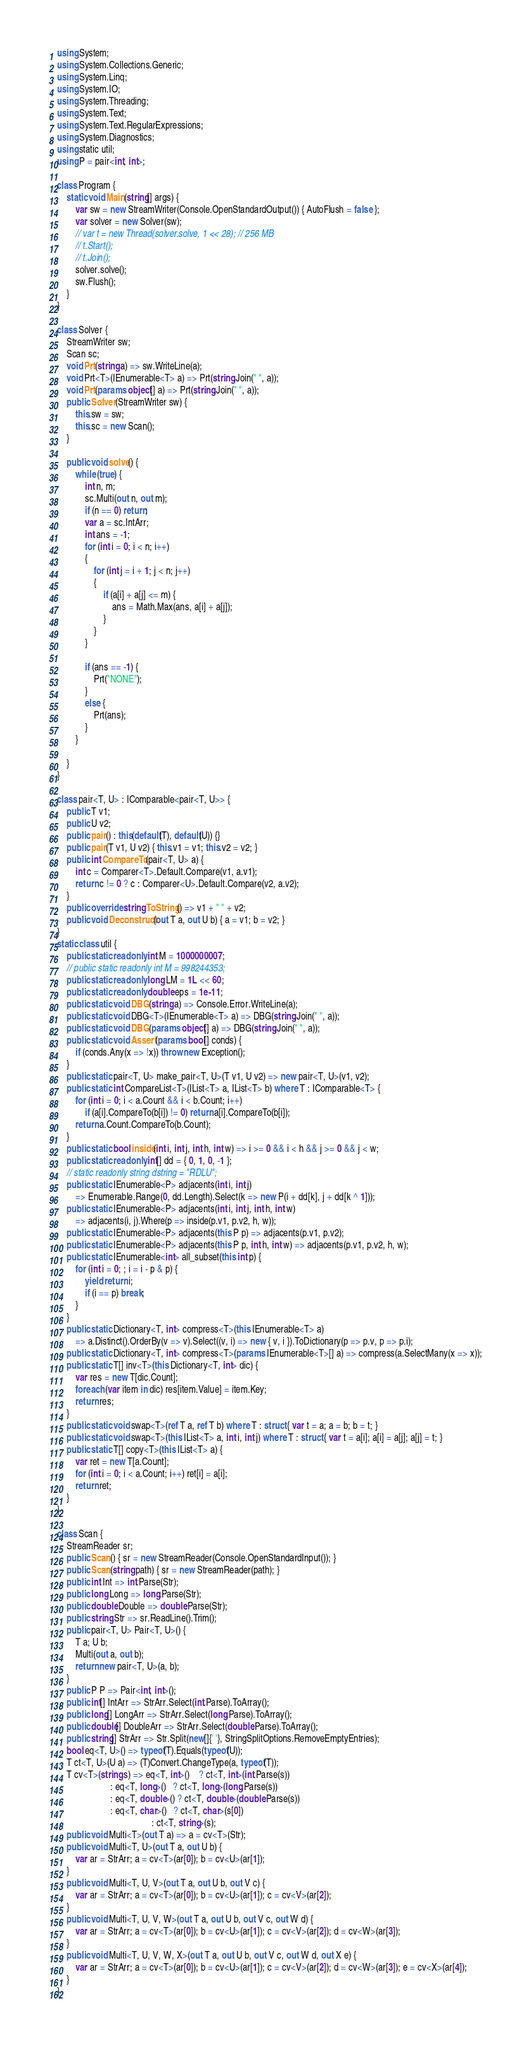<code> <loc_0><loc_0><loc_500><loc_500><_C#_>using System;
using System.Collections.Generic;
using System.Linq;
using System.IO;
using System.Threading;
using System.Text;
using System.Text.RegularExpressions;
using System.Diagnostics;
using static util;
using P = pair<int, int>;

class Program {
    static void Main(string[] args) {
        var sw = new StreamWriter(Console.OpenStandardOutput()) { AutoFlush = false };
        var solver = new Solver(sw);
        // var t = new Thread(solver.solve, 1 << 28); // 256 MB
        // t.Start();
        // t.Join();
        solver.solve();
        sw.Flush();
    }
}

class Solver {
    StreamWriter sw;
    Scan sc;
    void Prt(string a) => sw.WriteLine(a);
    void Prt<T>(IEnumerable<T> a) => Prt(string.Join(" ", a));
    void Prt(params object[] a) => Prt(string.Join(" ", a));
    public Solver(StreamWriter sw) {
        this.sw = sw;
        this.sc = new Scan();
    }

    public void solve() {
        while (true) {
            int n, m;
            sc.Multi(out n, out m);
            if (n == 0) return;
            var a = sc.IntArr;
            int ans = -1;
            for (int i = 0; i < n; i++)
            {
                for (int j = i + 1; j < n; j++)
                {
                    if (a[i] + a[j] <= m) {
                        ans = Math.Max(ans, a[i] + a[j]);
                    }
                }
            }

            if (ans == -1) {
                Prt("NONE");
            }
            else {
                Prt(ans);
            }
        }

    }
}

class pair<T, U> : IComparable<pair<T, U>> {
    public T v1;
    public U v2;
    public pair() : this(default(T), default(U)) {}
    public pair(T v1, U v2) { this.v1 = v1; this.v2 = v2; }
    public int CompareTo(pair<T, U> a) {
        int c = Comparer<T>.Default.Compare(v1, a.v1);
        return c != 0 ? c : Comparer<U>.Default.Compare(v2, a.v2);
    }
    public override string ToString() => v1 + " " + v2;
    public void Deconstruct(out T a, out U b) { a = v1; b = v2; }
}
static class util {
    public static readonly int M = 1000000007;
    // public static readonly int M = 998244353;
    public static readonly long LM = 1L << 60;
    public static readonly double eps = 1e-11;
    public static void DBG(string a) => Console.Error.WriteLine(a);
    public static void DBG<T>(IEnumerable<T> a) => DBG(string.Join(" ", a));
    public static void DBG(params object[] a) => DBG(string.Join(" ", a));
    public static void Assert(params bool[] conds) {
        if (conds.Any(x => !x)) throw new Exception();
    }
    public static pair<T, U> make_pair<T, U>(T v1, U v2) => new pair<T, U>(v1, v2);
    public static int CompareList<T>(IList<T> a, IList<T> b) where T : IComparable<T> {
        for (int i = 0; i < a.Count && i < b.Count; i++)
            if (a[i].CompareTo(b[i]) != 0) return a[i].CompareTo(b[i]);
        return a.Count.CompareTo(b.Count);
    }
    public static bool inside(int i, int j, int h, int w) => i >= 0 && i < h && j >= 0 && j < w;
    public static readonly int[] dd = { 0, 1, 0, -1 };
    // static readonly string dstring = "RDLU";
    public static IEnumerable<P> adjacents(int i, int j)
        => Enumerable.Range(0, dd.Length).Select(k => new P(i + dd[k], j + dd[k ^ 1]));
    public static IEnumerable<P> adjacents(int i, int j, int h, int w)
        => adjacents(i, j).Where(p => inside(p.v1, p.v2, h, w));
    public static IEnumerable<P> adjacents(this P p) => adjacents(p.v1, p.v2);
    public static IEnumerable<P> adjacents(this P p, int h, int w) => adjacents(p.v1, p.v2, h, w);
    public static IEnumerable<int> all_subset(this int p) {
        for (int i = 0; ; i = i - p & p) {
            yield return i;
            if (i == p) break;
        }
    }
    public static Dictionary<T, int> compress<T>(this IEnumerable<T> a)
        => a.Distinct().OrderBy(v => v).Select((v, i) => new { v, i }).ToDictionary(p => p.v, p => p.i);
    public static Dictionary<T, int> compress<T>(params IEnumerable<T>[] a) => compress(a.SelectMany(x => x));
    public static T[] inv<T>(this Dictionary<T, int> dic) {
        var res = new T[dic.Count];
        foreach (var item in dic) res[item.Value] = item.Key;
        return res;
    }
    public static void swap<T>(ref T a, ref T b) where T : struct { var t = a; a = b; b = t; }
    public static void swap<T>(this IList<T> a, int i, int j) where T : struct { var t = a[i]; a[i] = a[j]; a[j] = t; }
    public static T[] copy<T>(this IList<T> a) {
        var ret = new T[a.Count];
        for (int i = 0; i < a.Count; i++) ret[i] = a[i];
        return ret;
    }
}

class Scan {
    StreamReader sr;
    public Scan() { sr = new StreamReader(Console.OpenStandardInput()); }
    public Scan(string path) { sr = new StreamReader(path); }
    public int Int => int.Parse(Str);
    public long Long => long.Parse(Str);
    public double Double => double.Parse(Str);
    public string Str => sr.ReadLine().Trim();
    public pair<T, U> Pair<T, U>() {
        T a; U b;
        Multi(out a, out b);
        return new pair<T, U>(a, b);
    }
    public P P => Pair<int, int>();
    public int[] IntArr => StrArr.Select(int.Parse).ToArray();
    public long[] LongArr => StrArr.Select(long.Parse).ToArray();
    public double[] DoubleArr => StrArr.Select(double.Parse).ToArray();
    public string[] StrArr => Str.Split(new[]{' '}, StringSplitOptions.RemoveEmptyEntries);
    bool eq<T, U>() => typeof(T).Equals(typeof(U));
    T ct<T, U>(U a) => (T)Convert.ChangeType(a, typeof(T));
    T cv<T>(string s) => eq<T, int>()    ? ct<T, int>(int.Parse(s))
                       : eq<T, long>()   ? ct<T, long>(long.Parse(s))
                       : eq<T, double>() ? ct<T, double>(double.Parse(s))
                       : eq<T, char>()   ? ct<T, char>(s[0])
                                         : ct<T, string>(s);
    public void Multi<T>(out T a) => a = cv<T>(Str);
    public void Multi<T, U>(out T a, out U b) {
        var ar = StrArr; a = cv<T>(ar[0]); b = cv<U>(ar[1]);
    }
    public void Multi<T, U, V>(out T a, out U b, out V c) {
        var ar = StrArr; a = cv<T>(ar[0]); b = cv<U>(ar[1]); c = cv<V>(ar[2]);
    }
    public void Multi<T, U, V, W>(out T a, out U b, out V c, out W d) {
        var ar = StrArr; a = cv<T>(ar[0]); b = cv<U>(ar[1]); c = cv<V>(ar[2]); d = cv<W>(ar[3]);
    }
    public void Multi<T, U, V, W, X>(out T a, out U b, out V c, out W d, out X e) {
        var ar = StrArr; a = cv<T>(ar[0]); b = cv<U>(ar[1]); c = cv<V>(ar[2]); d = cv<W>(ar[3]); e = cv<X>(ar[4]);
    }
}

</code> 